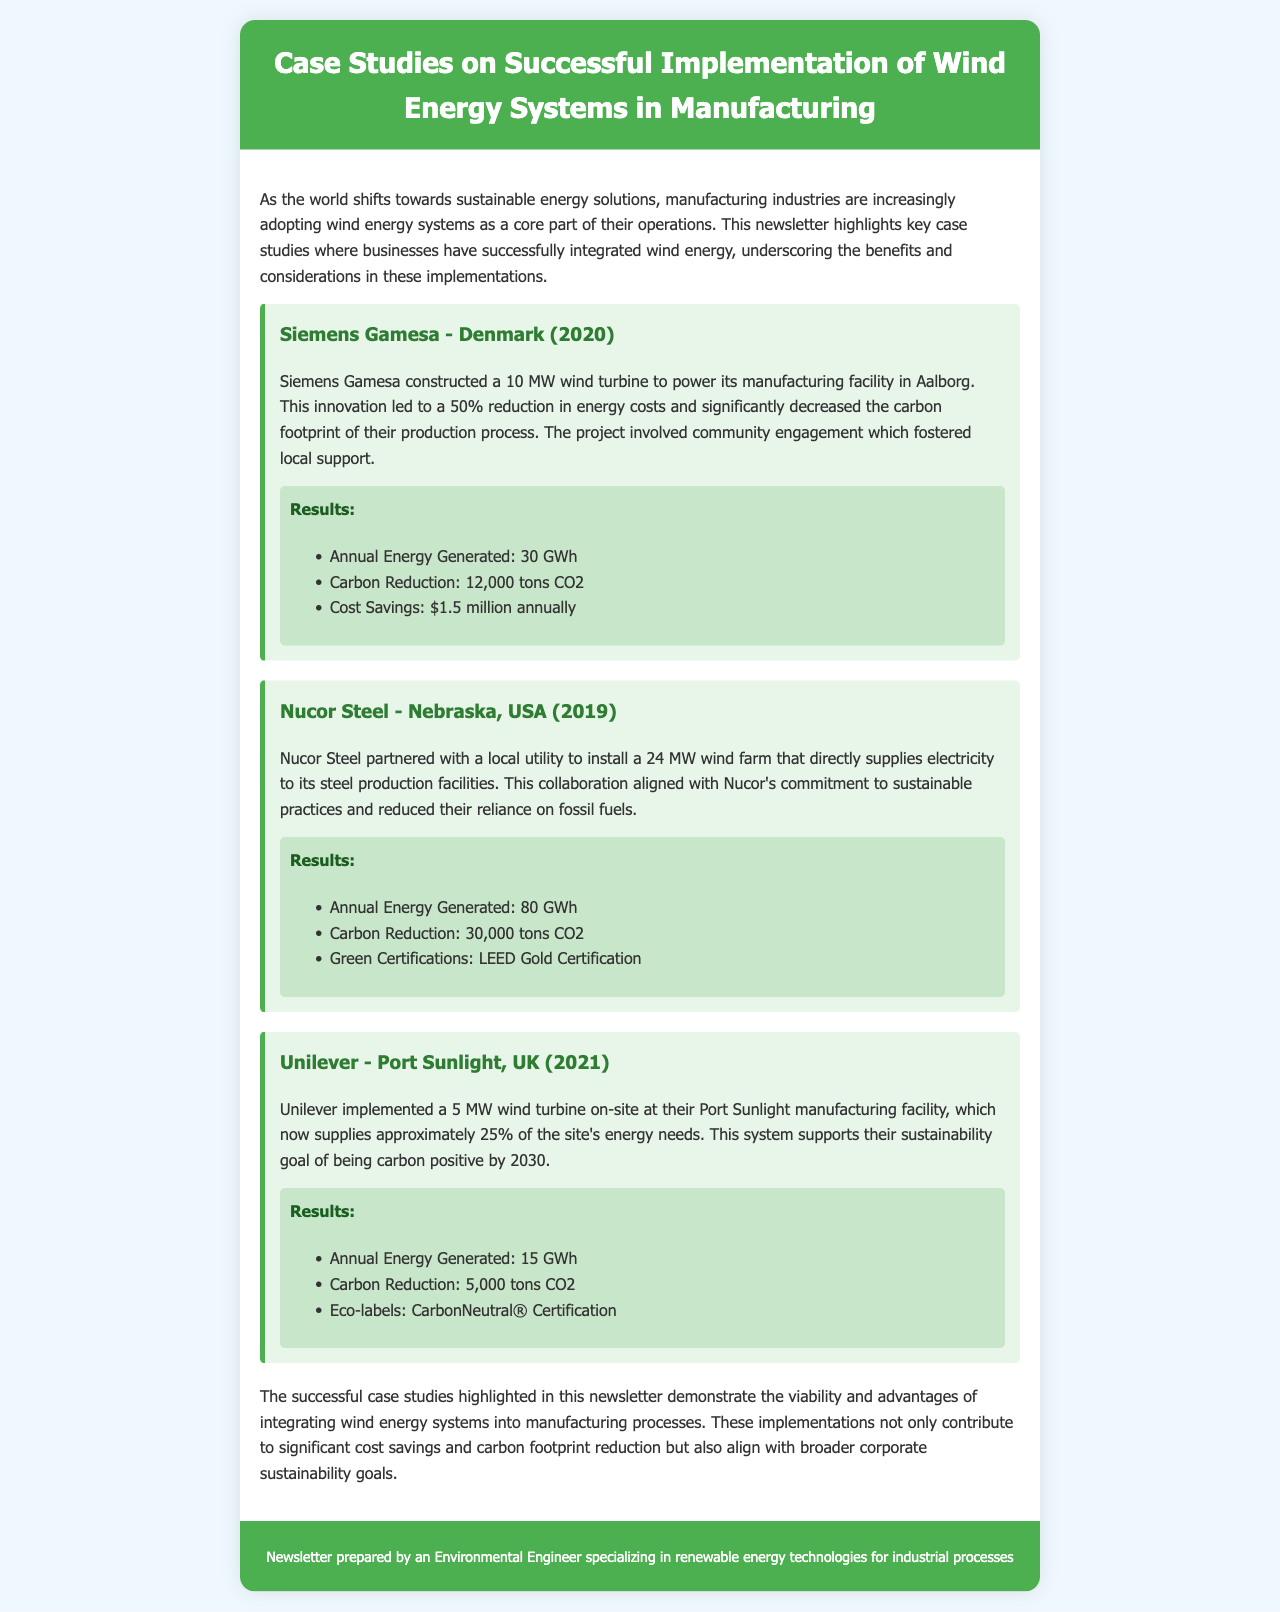What year did Siemens Gamesa implement their wind turbine? The document states that Siemens Gamesa constructed a wind turbine in 2020.
Answer: 2020 How much energy did Nucor Steel's wind farm generate annually? The annual energy generated by Nucor Steel's wind farm is mentioned as 80 GWh.
Answer: 80 GWh What percentage of its energy needs does Unilever's turbine supply? The document specifies that Unilever's turbine supplies approximately 25% of the site's energy needs.
Answer: 25% What was the carbon reduction achieved by Siemens Gamesa? Siemens Gamesa was able to reduce carbon emissions by 12,000 tons CO2.
Answer: 12,000 tons CO2 Which company achieved LEED Gold Certification? The document indicates that Nucor Steel achieved LEED Gold Certification.
Answer: Nucor Steel What is the total annual energy generated by Unilever's wind turbine? The total annual energy generated by Unilever is stated as 15 GWh.
Answer: 15 GWh What type of certification was Unilever awarded? The document mentions that Unilever received CarbonNeutral® Certification.
Answer: CarbonNeutral® Certification What is one of the main drivers for Siemens Gamesa's wind energy implementation? The document highlights that community engagement was a key driver for Siemens Gamesa's project.
Answer: Community engagement 